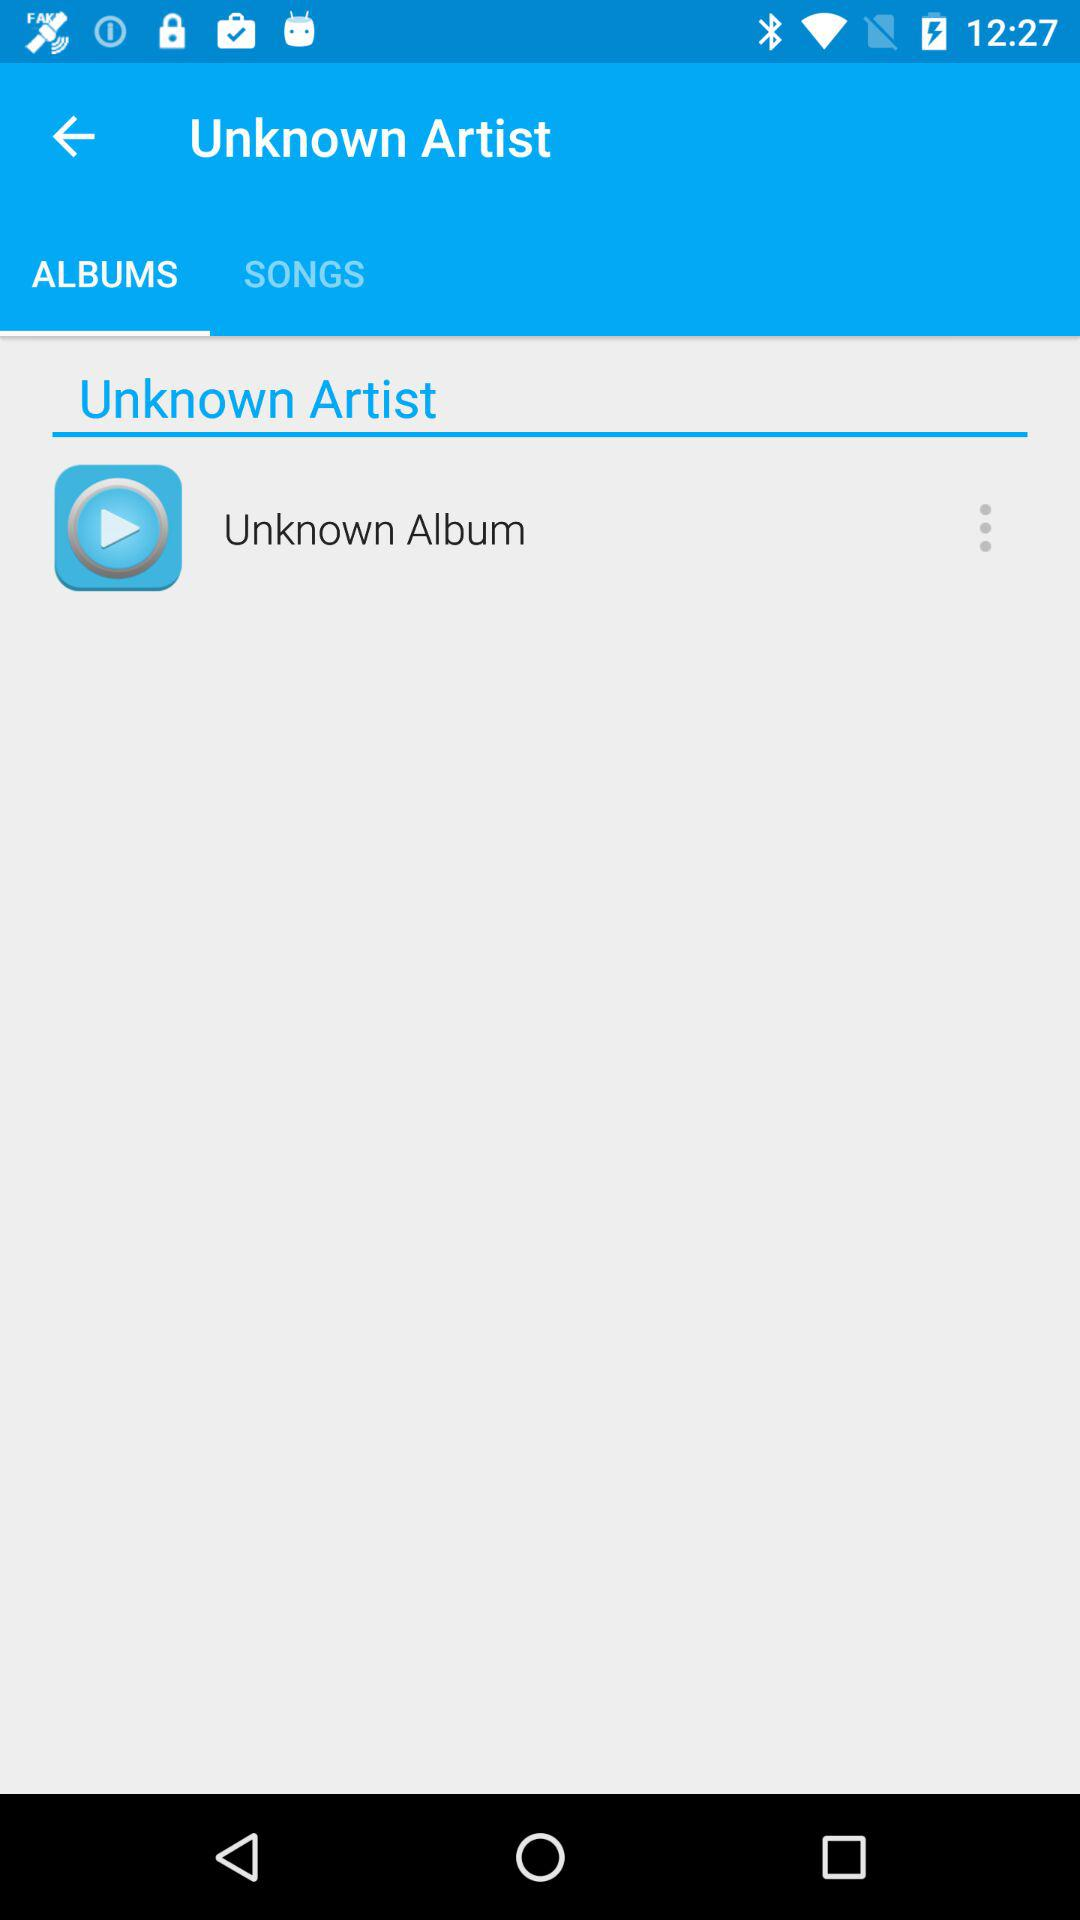What is the selected tab? The selected tab is "ALBUMS". 